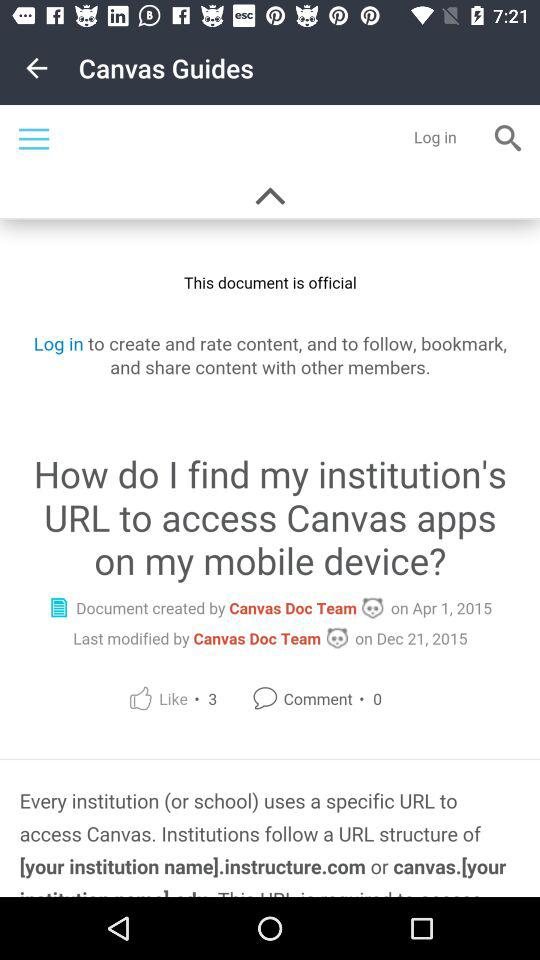How many comments are there for the document? There are 0 comments for the document. 